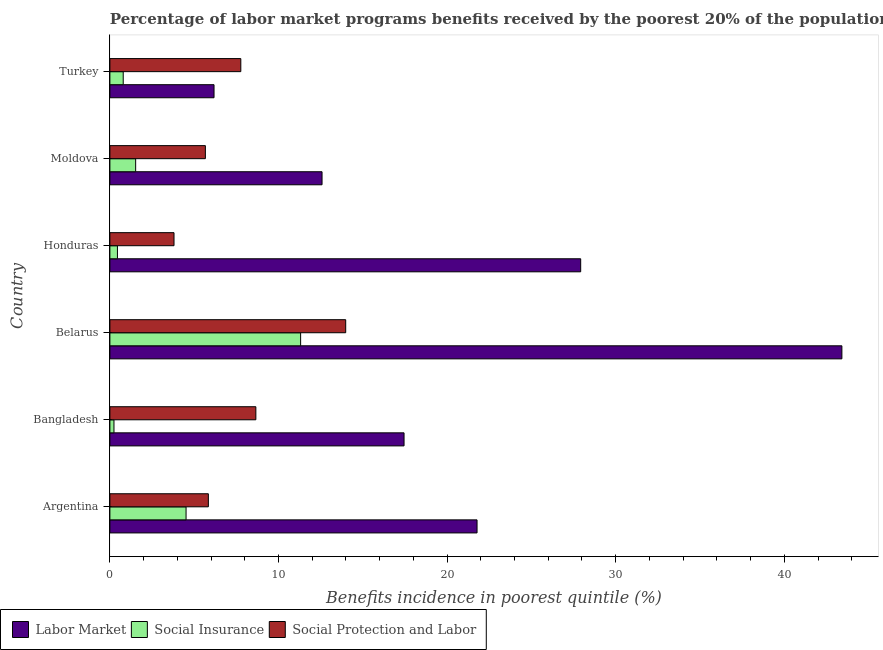How many different coloured bars are there?
Your answer should be compact. 3. Are the number of bars per tick equal to the number of legend labels?
Your answer should be very brief. Yes. Are the number of bars on each tick of the Y-axis equal?
Keep it short and to the point. Yes. How many bars are there on the 2nd tick from the top?
Offer a very short reply. 3. What is the label of the 2nd group of bars from the top?
Offer a very short reply. Moldova. In how many cases, is the number of bars for a given country not equal to the number of legend labels?
Ensure brevity in your answer.  0. What is the percentage of benefits received due to labor market programs in Moldova?
Your answer should be compact. 12.58. Across all countries, what is the maximum percentage of benefits received due to social insurance programs?
Provide a short and direct response. 11.31. Across all countries, what is the minimum percentage of benefits received due to labor market programs?
Ensure brevity in your answer.  6.18. In which country was the percentage of benefits received due to social insurance programs maximum?
Your answer should be very brief. Belarus. What is the total percentage of benefits received due to social insurance programs in the graph?
Provide a short and direct response. 18.84. What is the difference between the percentage of benefits received due to social insurance programs in Bangladesh and that in Belarus?
Make the answer very short. -11.07. What is the difference between the percentage of benefits received due to labor market programs in Argentina and the percentage of benefits received due to social protection programs in Turkey?
Your response must be concise. 14.01. What is the average percentage of benefits received due to social insurance programs per country?
Keep it short and to the point. 3.14. What is the difference between the percentage of benefits received due to labor market programs and percentage of benefits received due to social insurance programs in Bangladesh?
Provide a short and direct response. 17.2. In how many countries, is the percentage of benefits received due to social insurance programs greater than 36 %?
Your answer should be compact. 0. What is the ratio of the percentage of benefits received due to social insurance programs in Moldova to that in Turkey?
Give a very brief answer. 1.93. Is the percentage of benefits received due to labor market programs in Argentina less than that in Bangladesh?
Give a very brief answer. No. Is the difference between the percentage of benefits received due to social insurance programs in Argentina and Belarus greater than the difference between the percentage of benefits received due to labor market programs in Argentina and Belarus?
Your response must be concise. Yes. What is the difference between the highest and the second highest percentage of benefits received due to labor market programs?
Offer a terse response. 15.49. What is the difference between the highest and the lowest percentage of benefits received due to social insurance programs?
Ensure brevity in your answer.  11.07. In how many countries, is the percentage of benefits received due to labor market programs greater than the average percentage of benefits received due to labor market programs taken over all countries?
Offer a terse response. 3. Is the sum of the percentage of benefits received due to social insurance programs in Bangladesh and Belarus greater than the maximum percentage of benefits received due to labor market programs across all countries?
Keep it short and to the point. No. What does the 2nd bar from the top in Honduras represents?
Give a very brief answer. Social Insurance. What does the 1st bar from the bottom in Bangladesh represents?
Provide a short and direct response. Labor Market. Is it the case that in every country, the sum of the percentage of benefits received due to labor market programs and percentage of benefits received due to social insurance programs is greater than the percentage of benefits received due to social protection programs?
Give a very brief answer. No. How many bars are there?
Your answer should be very brief. 18. Are all the bars in the graph horizontal?
Provide a short and direct response. Yes. How many countries are there in the graph?
Your answer should be compact. 6. Are the values on the major ticks of X-axis written in scientific E-notation?
Offer a very short reply. No. Does the graph contain grids?
Provide a short and direct response. No. Where does the legend appear in the graph?
Offer a terse response. Bottom left. How many legend labels are there?
Provide a succinct answer. 3. What is the title of the graph?
Provide a short and direct response. Percentage of labor market programs benefits received by the poorest 20% of the population of countries. What is the label or title of the X-axis?
Keep it short and to the point. Benefits incidence in poorest quintile (%). What is the label or title of the Y-axis?
Your response must be concise. Country. What is the Benefits incidence in poorest quintile (%) of Labor Market in Argentina?
Make the answer very short. 21.78. What is the Benefits incidence in poorest quintile (%) of Social Insurance in Argentina?
Your answer should be compact. 4.52. What is the Benefits incidence in poorest quintile (%) in Social Protection and Labor in Argentina?
Offer a terse response. 5.84. What is the Benefits incidence in poorest quintile (%) of Labor Market in Bangladesh?
Offer a terse response. 17.45. What is the Benefits incidence in poorest quintile (%) of Social Insurance in Bangladesh?
Your response must be concise. 0.24. What is the Benefits incidence in poorest quintile (%) of Social Protection and Labor in Bangladesh?
Offer a very short reply. 8.66. What is the Benefits incidence in poorest quintile (%) of Labor Market in Belarus?
Provide a short and direct response. 43.42. What is the Benefits incidence in poorest quintile (%) of Social Insurance in Belarus?
Keep it short and to the point. 11.31. What is the Benefits incidence in poorest quintile (%) in Social Protection and Labor in Belarus?
Offer a terse response. 13.99. What is the Benefits incidence in poorest quintile (%) in Labor Market in Honduras?
Provide a succinct answer. 27.92. What is the Benefits incidence in poorest quintile (%) in Social Insurance in Honduras?
Ensure brevity in your answer.  0.45. What is the Benefits incidence in poorest quintile (%) of Social Protection and Labor in Honduras?
Ensure brevity in your answer.  3.8. What is the Benefits incidence in poorest quintile (%) in Labor Market in Moldova?
Provide a short and direct response. 12.58. What is the Benefits incidence in poorest quintile (%) in Social Insurance in Moldova?
Give a very brief answer. 1.53. What is the Benefits incidence in poorest quintile (%) in Social Protection and Labor in Moldova?
Give a very brief answer. 5.66. What is the Benefits incidence in poorest quintile (%) in Labor Market in Turkey?
Your response must be concise. 6.18. What is the Benefits incidence in poorest quintile (%) of Social Insurance in Turkey?
Your response must be concise. 0.79. What is the Benefits incidence in poorest quintile (%) of Social Protection and Labor in Turkey?
Ensure brevity in your answer.  7.76. Across all countries, what is the maximum Benefits incidence in poorest quintile (%) in Labor Market?
Give a very brief answer. 43.42. Across all countries, what is the maximum Benefits incidence in poorest quintile (%) of Social Insurance?
Make the answer very short. 11.31. Across all countries, what is the maximum Benefits incidence in poorest quintile (%) of Social Protection and Labor?
Offer a terse response. 13.99. Across all countries, what is the minimum Benefits incidence in poorest quintile (%) of Labor Market?
Provide a short and direct response. 6.18. Across all countries, what is the minimum Benefits incidence in poorest quintile (%) of Social Insurance?
Provide a succinct answer. 0.24. Across all countries, what is the minimum Benefits incidence in poorest quintile (%) of Social Protection and Labor?
Provide a short and direct response. 3.8. What is the total Benefits incidence in poorest quintile (%) of Labor Market in the graph?
Your response must be concise. 129.32. What is the total Benefits incidence in poorest quintile (%) of Social Insurance in the graph?
Offer a terse response. 18.84. What is the total Benefits incidence in poorest quintile (%) in Social Protection and Labor in the graph?
Keep it short and to the point. 45.71. What is the difference between the Benefits incidence in poorest quintile (%) in Labor Market in Argentina and that in Bangladesh?
Provide a succinct answer. 4.33. What is the difference between the Benefits incidence in poorest quintile (%) in Social Insurance in Argentina and that in Bangladesh?
Keep it short and to the point. 4.28. What is the difference between the Benefits incidence in poorest quintile (%) of Social Protection and Labor in Argentina and that in Bangladesh?
Your answer should be compact. -2.82. What is the difference between the Benefits incidence in poorest quintile (%) of Labor Market in Argentina and that in Belarus?
Ensure brevity in your answer.  -21.64. What is the difference between the Benefits incidence in poorest quintile (%) of Social Insurance in Argentina and that in Belarus?
Provide a succinct answer. -6.79. What is the difference between the Benefits incidence in poorest quintile (%) in Social Protection and Labor in Argentina and that in Belarus?
Provide a short and direct response. -8.15. What is the difference between the Benefits incidence in poorest quintile (%) in Labor Market in Argentina and that in Honduras?
Ensure brevity in your answer.  -6.15. What is the difference between the Benefits incidence in poorest quintile (%) of Social Insurance in Argentina and that in Honduras?
Provide a succinct answer. 4.07. What is the difference between the Benefits incidence in poorest quintile (%) in Social Protection and Labor in Argentina and that in Honduras?
Ensure brevity in your answer.  2.04. What is the difference between the Benefits incidence in poorest quintile (%) of Labor Market in Argentina and that in Moldova?
Provide a succinct answer. 9.19. What is the difference between the Benefits incidence in poorest quintile (%) of Social Insurance in Argentina and that in Moldova?
Your answer should be compact. 2.99. What is the difference between the Benefits incidence in poorest quintile (%) of Social Protection and Labor in Argentina and that in Moldova?
Provide a short and direct response. 0.18. What is the difference between the Benefits incidence in poorest quintile (%) of Labor Market in Argentina and that in Turkey?
Your answer should be very brief. 15.6. What is the difference between the Benefits incidence in poorest quintile (%) of Social Insurance in Argentina and that in Turkey?
Your answer should be compact. 3.73. What is the difference between the Benefits incidence in poorest quintile (%) in Social Protection and Labor in Argentina and that in Turkey?
Ensure brevity in your answer.  -1.92. What is the difference between the Benefits incidence in poorest quintile (%) in Labor Market in Bangladesh and that in Belarus?
Provide a short and direct response. -25.97. What is the difference between the Benefits incidence in poorest quintile (%) of Social Insurance in Bangladesh and that in Belarus?
Keep it short and to the point. -11.07. What is the difference between the Benefits incidence in poorest quintile (%) in Social Protection and Labor in Bangladesh and that in Belarus?
Make the answer very short. -5.33. What is the difference between the Benefits incidence in poorest quintile (%) of Labor Market in Bangladesh and that in Honduras?
Keep it short and to the point. -10.48. What is the difference between the Benefits incidence in poorest quintile (%) in Social Insurance in Bangladesh and that in Honduras?
Make the answer very short. -0.21. What is the difference between the Benefits incidence in poorest quintile (%) in Social Protection and Labor in Bangladesh and that in Honduras?
Provide a short and direct response. 4.85. What is the difference between the Benefits incidence in poorest quintile (%) in Labor Market in Bangladesh and that in Moldova?
Keep it short and to the point. 4.86. What is the difference between the Benefits incidence in poorest quintile (%) of Social Insurance in Bangladesh and that in Moldova?
Give a very brief answer. -1.29. What is the difference between the Benefits incidence in poorest quintile (%) of Social Protection and Labor in Bangladesh and that in Moldova?
Your answer should be very brief. 2.99. What is the difference between the Benefits incidence in poorest quintile (%) in Labor Market in Bangladesh and that in Turkey?
Make the answer very short. 11.27. What is the difference between the Benefits incidence in poorest quintile (%) of Social Insurance in Bangladesh and that in Turkey?
Give a very brief answer. -0.55. What is the difference between the Benefits incidence in poorest quintile (%) in Social Protection and Labor in Bangladesh and that in Turkey?
Offer a very short reply. 0.89. What is the difference between the Benefits incidence in poorest quintile (%) in Labor Market in Belarus and that in Honduras?
Your answer should be very brief. 15.49. What is the difference between the Benefits incidence in poorest quintile (%) in Social Insurance in Belarus and that in Honduras?
Keep it short and to the point. 10.86. What is the difference between the Benefits incidence in poorest quintile (%) of Social Protection and Labor in Belarus and that in Honduras?
Give a very brief answer. 10.18. What is the difference between the Benefits incidence in poorest quintile (%) in Labor Market in Belarus and that in Moldova?
Your answer should be very brief. 30.83. What is the difference between the Benefits incidence in poorest quintile (%) in Social Insurance in Belarus and that in Moldova?
Give a very brief answer. 9.78. What is the difference between the Benefits incidence in poorest quintile (%) of Social Protection and Labor in Belarus and that in Moldova?
Provide a short and direct response. 8.32. What is the difference between the Benefits incidence in poorest quintile (%) in Labor Market in Belarus and that in Turkey?
Provide a succinct answer. 37.24. What is the difference between the Benefits incidence in poorest quintile (%) in Social Insurance in Belarus and that in Turkey?
Make the answer very short. 10.52. What is the difference between the Benefits incidence in poorest quintile (%) of Social Protection and Labor in Belarus and that in Turkey?
Your response must be concise. 6.22. What is the difference between the Benefits incidence in poorest quintile (%) of Labor Market in Honduras and that in Moldova?
Your answer should be very brief. 15.34. What is the difference between the Benefits incidence in poorest quintile (%) in Social Insurance in Honduras and that in Moldova?
Provide a succinct answer. -1.08. What is the difference between the Benefits incidence in poorest quintile (%) in Social Protection and Labor in Honduras and that in Moldova?
Give a very brief answer. -1.86. What is the difference between the Benefits incidence in poorest quintile (%) of Labor Market in Honduras and that in Turkey?
Make the answer very short. 21.75. What is the difference between the Benefits incidence in poorest quintile (%) of Social Insurance in Honduras and that in Turkey?
Offer a very short reply. -0.34. What is the difference between the Benefits incidence in poorest quintile (%) of Social Protection and Labor in Honduras and that in Turkey?
Make the answer very short. -3.96. What is the difference between the Benefits incidence in poorest quintile (%) of Labor Market in Moldova and that in Turkey?
Your response must be concise. 6.41. What is the difference between the Benefits incidence in poorest quintile (%) in Social Insurance in Moldova and that in Turkey?
Your answer should be very brief. 0.74. What is the difference between the Benefits incidence in poorest quintile (%) in Social Protection and Labor in Moldova and that in Turkey?
Your answer should be very brief. -2.1. What is the difference between the Benefits incidence in poorest quintile (%) of Labor Market in Argentina and the Benefits incidence in poorest quintile (%) of Social Insurance in Bangladesh?
Your answer should be very brief. 21.53. What is the difference between the Benefits incidence in poorest quintile (%) in Labor Market in Argentina and the Benefits incidence in poorest quintile (%) in Social Protection and Labor in Bangladesh?
Ensure brevity in your answer.  13.12. What is the difference between the Benefits incidence in poorest quintile (%) in Social Insurance in Argentina and the Benefits incidence in poorest quintile (%) in Social Protection and Labor in Bangladesh?
Offer a very short reply. -4.14. What is the difference between the Benefits incidence in poorest quintile (%) of Labor Market in Argentina and the Benefits incidence in poorest quintile (%) of Social Insurance in Belarus?
Offer a very short reply. 10.46. What is the difference between the Benefits incidence in poorest quintile (%) in Labor Market in Argentina and the Benefits incidence in poorest quintile (%) in Social Protection and Labor in Belarus?
Ensure brevity in your answer.  7.79. What is the difference between the Benefits incidence in poorest quintile (%) of Social Insurance in Argentina and the Benefits incidence in poorest quintile (%) of Social Protection and Labor in Belarus?
Ensure brevity in your answer.  -9.47. What is the difference between the Benefits incidence in poorest quintile (%) of Labor Market in Argentina and the Benefits incidence in poorest quintile (%) of Social Insurance in Honduras?
Offer a very short reply. 21.33. What is the difference between the Benefits incidence in poorest quintile (%) in Labor Market in Argentina and the Benefits incidence in poorest quintile (%) in Social Protection and Labor in Honduras?
Your answer should be very brief. 17.97. What is the difference between the Benefits incidence in poorest quintile (%) of Social Insurance in Argentina and the Benefits incidence in poorest quintile (%) of Social Protection and Labor in Honduras?
Keep it short and to the point. 0.72. What is the difference between the Benefits incidence in poorest quintile (%) of Labor Market in Argentina and the Benefits incidence in poorest quintile (%) of Social Insurance in Moldova?
Ensure brevity in your answer.  20.25. What is the difference between the Benefits incidence in poorest quintile (%) in Labor Market in Argentina and the Benefits incidence in poorest quintile (%) in Social Protection and Labor in Moldova?
Your response must be concise. 16.11. What is the difference between the Benefits incidence in poorest quintile (%) of Social Insurance in Argentina and the Benefits incidence in poorest quintile (%) of Social Protection and Labor in Moldova?
Your answer should be compact. -1.14. What is the difference between the Benefits incidence in poorest quintile (%) in Labor Market in Argentina and the Benefits incidence in poorest quintile (%) in Social Insurance in Turkey?
Your response must be concise. 20.99. What is the difference between the Benefits incidence in poorest quintile (%) in Labor Market in Argentina and the Benefits incidence in poorest quintile (%) in Social Protection and Labor in Turkey?
Your answer should be compact. 14.01. What is the difference between the Benefits incidence in poorest quintile (%) in Social Insurance in Argentina and the Benefits incidence in poorest quintile (%) in Social Protection and Labor in Turkey?
Your response must be concise. -3.25. What is the difference between the Benefits incidence in poorest quintile (%) of Labor Market in Bangladesh and the Benefits incidence in poorest quintile (%) of Social Insurance in Belarus?
Offer a very short reply. 6.13. What is the difference between the Benefits incidence in poorest quintile (%) of Labor Market in Bangladesh and the Benefits incidence in poorest quintile (%) of Social Protection and Labor in Belarus?
Your answer should be very brief. 3.46. What is the difference between the Benefits incidence in poorest quintile (%) of Social Insurance in Bangladesh and the Benefits incidence in poorest quintile (%) of Social Protection and Labor in Belarus?
Your answer should be compact. -13.74. What is the difference between the Benefits incidence in poorest quintile (%) in Labor Market in Bangladesh and the Benefits incidence in poorest quintile (%) in Social Insurance in Honduras?
Offer a terse response. 17. What is the difference between the Benefits incidence in poorest quintile (%) of Labor Market in Bangladesh and the Benefits incidence in poorest quintile (%) of Social Protection and Labor in Honduras?
Your answer should be very brief. 13.64. What is the difference between the Benefits incidence in poorest quintile (%) in Social Insurance in Bangladesh and the Benefits incidence in poorest quintile (%) in Social Protection and Labor in Honduras?
Provide a short and direct response. -3.56. What is the difference between the Benefits incidence in poorest quintile (%) in Labor Market in Bangladesh and the Benefits incidence in poorest quintile (%) in Social Insurance in Moldova?
Provide a succinct answer. 15.92. What is the difference between the Benefits incidence in poorest quintile (%) in Labor Market in Bangladesh and the Benefits incidence in poorest quintile (%) in Social Protection and Labor in Moldova?
Provide a succinct answer. 11.78. What is the difference between the Benefits incidence in poorest quintile (%) of Social Insurance in Bangladesh and the Benefits incidence in poorest quintile (%) of Social Protection and Labor in Moldova?
Your response must be concise. -5.42. What is the difference between the Benefits incidence in poorest quintile (%) of Labor Market in Bangladesh and the Benefits incidence in poorest quintile (%) of Social Insurance in Turkey?
Offer a terse response. 16.66. What is the difference between the Benefits incidence in poorest quintile (%) in Labor Market in Bangladesh and the Benefits incidence in poorest quintile (%) in Social Protection and Labor in Turkey?
Your response must be concise. 9.68. What is the difference between the Benefits incidence in poorest quintile (%) in Social Insurance in Bangladesh and the Benefits incidence in poorest quintile (%) in Social Protection and Labor in Turkey?
Provide a succinct answer. -7.52. What is the difference between the Benefits incidence in poorest quintile (%) in Labor Market in Belarus and the Benefits incidence in poorest quintile (%) in Social Insurance in Honduras?
Provide a short and direct response. 42.97. What is the difference between the Benefits incidence in poorest quintile (%) of Labor Market in Belarus and the Benefits incidence in poorest quintile (%) of Social Protection and Labor in Honduras?
Offer a terse response. 39.61. What is the difference between the Benefits incidence in poorest quintile (%) in Social Insurance in Belarus and the Benefits incidence in poorest quintile (%) in Social Protection and Labor in Honduras?
Your answer should be very brief. 7.51. What is the difference between the Benefits incidence in poorest quintile (%) in Labor Market in Belarus and the Benefits incidence in poorest quintile (%) in Social Insurance in Moldova?
Provide a short and direct response. 41.89. What is the difference between the Benefits incidence in poorest quintile (%) of Labor Market in Belarus and the Benefits incidence in poorest quintile (%) of Social Protection and Labor in Moldova?
Offer a terse response. 37.75. What is the difference between the Benefits incidence in poorest quintile (%) in Social Insurance in Belarus and the Benefits incidence in poorest quintile (%) in Social Protection and Labor in Moldova?
Keep it short and to the point. 5.65. What is the difference between the Benefits incidence in poorest quintile (%) in Labor Market in Belarus and the Benefits incidence in poorest quintile (%) in Social Insurance in Turkey?
Ensure brevity in your answer.  42.63. What is the difference between the Benefits incidence in poorest quintile (%) of Labor Market in Belarus and the Benefits incidence in poorest quintile (%) of Social Protection and Labor in Turkey?
Provide a short and direct response. 35.65. What is the difference between the Benefits incidence in poorest quintile (%) of Social Insurance in Belarus and the Benefits incidence in poorest quintile (%) of Social Protection and Labor in Turkey?
Your answer should be compact. 3.55. What is the difference between the Benefits incidence in poorest quintile (%) in Labor Market in Honduras and the Benefits incidence in poorest quintile (%) in Social Insurance in Moldova?
Provide a short and direct response. 26.4. What is the difference between the Benefits incidence in poorest quintile (%) in Labor Market in Honduras and the Benefits incidence in poorest quintile (%) in Social Protection and Labor in Moldova?
Give a very brief answer. 22.26. What is the difference between the Benefits incidence in poorest quintile (%) of Social Insurance in Honduras and the Benefits incidence in poorest quintile (%) of Social Protection and Labor in Moldova?
Your response must be concise. -5.21. What is the difference between the Benefits incidence in poorest quintile (%) of Labor Market in Honduras and the Benefits incidence in poorest quintile (%) of Social Insurance in Turkey?
Ensure brevity in your answer.  27.13. What is the difference between the Benefits incidence in poorest quintile (%) in Labor Market in Honduras and the Benefits incidence in poorest quintile (%) in Social Protection and Labor in Turkey?
Keep it short and to the point. 20.16. What is the difference between the Benefits incidence in poorest quintile (%) of Social Insurance in Honduras and the Benefits incidence in poorest quintile (%) of Social Protection and Labor in Turkey?
Provide a short and direct response. -7.32. What is the difference between the Benefits incidence in poorest quintile (%) of Labor Market in Moldova and the Benefits incidence in poorest quintile (%) of Social Insurance in Turkey?
Offer a terse response. 11.79. What is the difference between the Benefits incidence in poorest quintile (%) in Labor Market in Moldova and the Benefits incidence in poorest quintile (%) in Social Protection and Labor in Turkey?
Make the answer very short. 4.82. What is the difference between the Benefits incidence in poorest quintile (%) in Social Insurance in Moldova and the Benefits incidence in poorest quintile (%) in Social Protection and Labor in Turkey?
Provide a short and direct response. -6.24. What is the average Benefits incidence in poorest quintile (%) of Labor Market per country?
Ensure brevity in your answer.  21.55. What is the average Benefits incidence in poorest quintile (%) of Social Insurance per country?
Provide a succinct answer. 3.14. What is the average Benefits incidence in poorest quintile (%) of Social Protection and Labor per country?
Keep it short and to the point. 7.62. What is the difference between the Benefits incidence in poorest quintile (%) of Labor Market and Benefits incidence in poorest quintile (%) of Social Insurance in Argentina?
Offer a very short reply. 17.26. What is the difference between the Benefits incidence in poorest quintile (%) of Labor Market and Benefits incidence in poorest quintile (%) of Social Protection and Labor in Argentina?
Your response must be concise. 15.94. What is the difference between the Benefits incidence in poorest quintile (%) in Social Insurance and Benefits incidence in poorest quintile (%) in Social Protection and Labor in Argentina?
Make the answer very short. -1.32. What is the difference between the Benefits incidence in poorest quintile (%) of Labor Market and Benefits incidence in poorest quintile (%) of Social Insurance in Bangladesh?
Provide a succinct answer. 17.21. What is the difference between the Benefits incidence in poorest quintile (%) of Labor Market and Benefits incidence in poorest quintile (%) of Social Protection and Labor in Bangladesh?
Your answer should be compact. 8.79. What is the difference between the Benefits incidence in poorest quintile (%) in Social Insurance and Benefits incidence in poorest quintile (%) in Social Protection and Labor in Bangladesh?
Make the answer very short. -8.42. What is the difference between the Benefits incidence in poorest quintile (%) in Labor Market and Benefits incidence in poorest quintile (%) in Social Insurance in Belarus?
Offer a terse response. 32.1. What is the difference between the Benefits incidence in poorest quintile (%) in Labor Market and Benefits incidence in poorest quintile (%) in Social Protection and Labor in Belarus?
Keep it short and to the point. 29.43. What is the difference between the Benefits incidence in poorest quintile (%) in Social Insurance and Benefits incidence in poorest quintile (%) in Social Protection and Labor in Belarus?
Give a very brief answer. -2.67. What is the difference between the Benefits incidence in poorest quintile (%) of Labor Market and Benefits incidence in poorest quintile (%) of Social Insurance in Honduras?
Your answer should be very brief. 27.48. What is the difference between the Benefits incidence in poorest quintile (%) in Labor Market and Benefits incidence in poorest quintile (%) in Social Protection and Labor in Honduras?
Offer a terse response. 24.12. What is the difference between the Benefits incidence in poorest quintile (%) in Social Insurance and Benefits incidence in poorest quintile (%) in Social Protection and Labor in Honduras?
Your answer should be very brief. -3.35. What is the difference between the Benefits incidence in poorest quintile (%) in Labor Market and Benefits incidence in poorest quintile (%) in Social Insurance in Moldova?
Offer a very short reply. 11.05. What is the difference between the Benefits incidence in poorest quintile (%) of Labor Market and Benefits incidence in poorest quintile (%) of Social Protection and Labor in Moldova?
Ensure brevity in your answer.  6.92. What is the difference between the Benefits incidence in poorest quintile (%) in Social Insurance and Benefits incidence in poorest quintile (%) in Social Protection and Labor in Moldova?
Keep it short and to the point. -4.13. What is the difference between the Benefits incidence in poorest quintile (%) of Labor Market and Benefits incidence in poorest quintile (%) of Social Insurance in Turkey?
Ensure brevity in your answer.  5.39. What is the difference between the Benefits incidence in poorest quintile (%) of Labor Market and Benefits incidence in poorest quintile (%) of Social Protection and Labor in Turkey?
Provide a succinct answer. -1.59. What is the difference between the Benefits incidence in poorest quintile (%) of Social Insurance and Benefits incidence in poorest quintile (%) of Social Protection and Labor in Turkey?
Offer a very short reply. -6.97. What is the ratio of the Benefits incidence in poorest quintile (%) in Labor Market in Argentina to that in Bangladesh?
Your response must be concise. 1.25. What is the ratio of the Benefits incidence in poorest quintile (%) of Social Insurance in Argentina to that in Bangladesh?
Offer a terse response. 18.67. What is the ratio of the Benefits incidence in poorest quintile (%) in Social Protection and Labor in Argentina to that in Bangladesh?
Provide a succinct answer. 0.67. What is the ratio of the Benefits incidence in poorest quintile (%) in Labor Market in Argentina to that in Belarus?
Make the answer very short. 0.5. What is the ratio of the Benefits incidence in poorest quintile (%) of Social Insurance in Argentina to that in Belarus?
Offer a very short reply. 0.4. What is the ratio of the Benefits incidence in poorest quintile (%) of Social Protection and Labor in Argentina to that in Belarus?
Give a very brief answer. 0.42. What is the ratio of the Benefits incidence in poorest quintile (%) in Labor Market in Argentina to that in Honduras?
Offer a terse response. 0.78. What is the ratio of the Benefits incidence in poorest quintile (%) in Social Insurance in Argentina to that in Honduras?
Offer a terse response. 10.09. What is the ratio of the Benefits incidence in poorest quintile (%) of Social Protection and Labor in Argentina to that in Honduras?
Give a very brief answer. 1.54. What is the ratio of the Benefits incidence in poorest quintile (%) in Labor Market in Argentina to that in Moldova?
Provide a short and direct response. 1.73. What is the ratio of the Benefits incidence in poorest quintile (%) in Social Insurance in Argentina to that in Moldova?
Provide a short and direct response. 2.96. What is the ratio of the Benefits incidence in poorest quintile (%) in Social Protection and Labor in Argentina to that in Moldova?
Give a very brief answer. 1.03. What is the ratio of the Benefits incidence in poorest quintile (%) of Labor Market in Argentina to that in Turkey?
Make the answer very short. 3.53. What is the ratio of the Benefits incidence in poorest quintile (%) in Social Insurance in Argentina to that in Turkey?
Your response must be concise. 5.72. What is the ratio of the Benefits incidence in poorest quintile (%) in Social Protection and Labor in Argentina to that in Turkey?
Keep it short and to the point. 0.75. What is the ratio of the Benefits incidence in poorest quintile (%) of Labor Market in Bangladesh to that in Belarus?
Offer a terse response. 0.4. What is the ratio of the Benefits incidence in poorest quintile (%) of Social Insurance in Bangladesh to that in Belarus?
Offer a terse response. 0.02. What is the ratio of the Benefits incidence in poorest quintile (%) in Social Protection and Labor in Bangladesh to that in Belarus?
Offer a terse response. 0.62. What is the ratio of the Benefits incidence in poorest quintile (%) in Labor Market in Bangladesh to that in Honduras?
Offer a very short reply. 0.62. What is the ratio of the Benefits incidence in poorest quintile (%) in Social Insurance in Bangladesh to that in Honduras?
Your answer should be compact. 0.54. What is the ratio of the Benefits incidence in poorest quintile (%) of Social Protection and Labor in Bangladesh to that in Honduras?
Your answer should be compact. 2.28. What is the ratio of the Benefits incidence in poorest quintile (%) of Labor Market in Bangladesh to that in Moldova?
Provide a succinct answer. 1.39. What is the ratio of the Benefits incidence in poorest quintile (%) in Social Insurance in Bangladesh to that in Moldova?
Your response must be concise. 0.16. What is the ratio of the Benefits incidence in poorest quintile (%) of Social Protection and Labor in Bangladesh to that in Moldova?
Provide a short and direct response. 1.53. What is the ratio of the Benefits incidence in poorest quintile (%) of Labor Market in Bangladesh to that in Turkey?
Your response must be concise. 2.82. What is the ratio of the Benefits incidence in poorest quintile (%) in Social Insurance in Bangladesh to that in Turkey?
Your response must be concise. 0.31. What is the ratio of the Benefits incidence in poorest quintile (%) in Social Protection and Labor in Bangladesh to that in Turkey?
Provide a short and direct response. 1.11. What is the ratio of the Benefits incidence in poorest quintile (%) of Labor Market in Belarus to that in Honduras?
Keep it short and to the point. 1.55. What is the ratio of the Benefits incidence in poorest quintile (%) in Social Insurance in Belarus to that in Honduras?
Offer a very short reply. 25.26. What is the ratio of the Benefits incidence in poorest quintile (%) of Social Protection and Labor in Belarus to that in Honduras?
Your answer should be very brief. 3.68. What is the ratio of the Benefits incidence in poorest quintile (%) of Labor Market in Belarus to that in Moldova?
Ensure brevity in your answer.  3.45. What is the ratio of the Benefits incidence in poorest quintile (%) of Social Insurance in Belarus to that in Moldova?
Make the answer very short. 7.4. What is the ratio of the Benefits incidence in poorest quintile (%) in Social Protection and Labor in Belarus to that in Moldova?
Make the answer very short. 2.47. What is the ratio of the Benefits incidence in poorest quintile (%) of Labor Market in Belarus to that in Turkey?
Your answer should be very brief. 7.03. What is the ratio of the Benefits incidence in poorest quintile (%) in Social Insurance in Belarus to that in Turkey?
Keep it short and to the point. 14.31. What is the ratio of the Benefits incidence in poorest quintile (%) in Social Protection and Labor in Belarus to that in Turkey?
Provide a short and direct response. 1.8. What is the ratio of the Benefits incidence in poorest quintile (%) of Labor Market in Honduras to that in Moldova?
Ensure brevity in your answer.  2.22. What is the ratio of the Benefits incidence in poorest quintile (%) of Social Insurance in Honduras to that in Moldova?
Make the answer very short. 0.29. What is the ratio of the Benefits incidence in poorest quintile (%) in Social Protection and Labor in Honduras to that in Moldova?
Give a very brief answer. 0.67. What is the ratio of the Benefits incidence in poorest quintile (%) in Labor Market in Honduras to that in Turkey?
Your answer should be very brief. 4.52. What is the ratio of the Benefits incidence in poorest quintile (%) in Social Insurance in Honduras to that in Turkey?
Provide a succinct answer. 0.57. What is the ratio of the Benefits incidence in poorest quintile (%) in Social Protection and Labor in Honduras to that in Turkey?
Keep it short and to the point. 0.49. What is the ratio of the Benefits incidence in poorest quintile (%) of Labor Market in Moldova to that in Turkey?
Your answer should be very brief. 2.04. What is the ratio of the Benefits incidence in poorest quintile (%) in Social Insurance in Moldova to that in Turkey?
Your answer should be very brief. 1.93. What is the ratio of the Benefits incidence in poorest quintile (%) in Social Protection and Labor in Moldova to that in Turkey?
Keep it short and to the point. 0.73. What is the difference between the highest and the second highest Benefits incidence in poorest quintile (%) of Labor Market?
Keep it short and to the point. 15.49. What is the difference between the highest and the second highest Benefits incidence in poorest quintile (%) in Social Insurance?
Offer a very short reply. 6.79. What is the difference between the highest and the second highest Benefits incidence in poorest quintile (%) in Social Protection and Labor?
Your answer should be compact. 5.33. What is the difference between the highest and the lowest Benefits incidence in poorest quintile (%) of Labor Market?
Offer a very short reply. 37.24. What is the difference between the highest and the lowest Benefits incidence in poorest quintile (%) of Social Insurance?
Your answer should be compact. 11.07. What is the difference between the highest and the lowest Benefits incidence in poorest quintile (%) of Social Protection and Labor?
Provide a short and direct response. 10.18. 